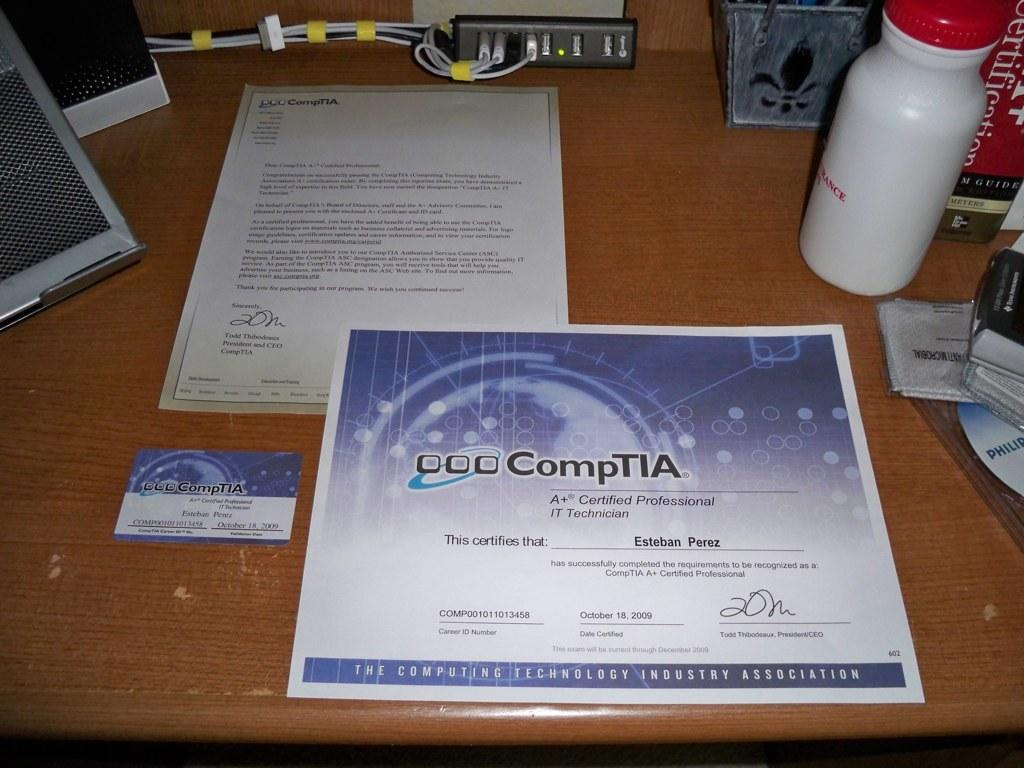Provide a one-sentence caption for the provided image. A + certification paper with a business card on a desk. 